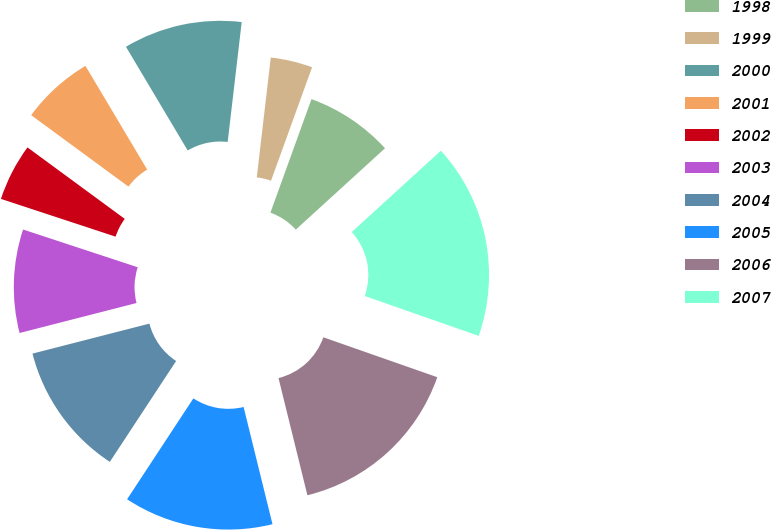<chart> <loc_0><loc_0><loc_500><loc_500><pie_chart><fcel>1998<fcel>1999<fcel>2000<fcel>2001<fcel>2002<fcel>2003<fcel>2004<fcel>2005<fcel>2006<fcel>2007<nl><fcel>7.71%<fcel>3.67%<fcel>10.4%<fcel>6.37%<fcel>5.02%<fcel>9.06%<fcel>11.75%<fcel>13.1%<fcel>15.79%<fcel>17.13%<nl></chart> 